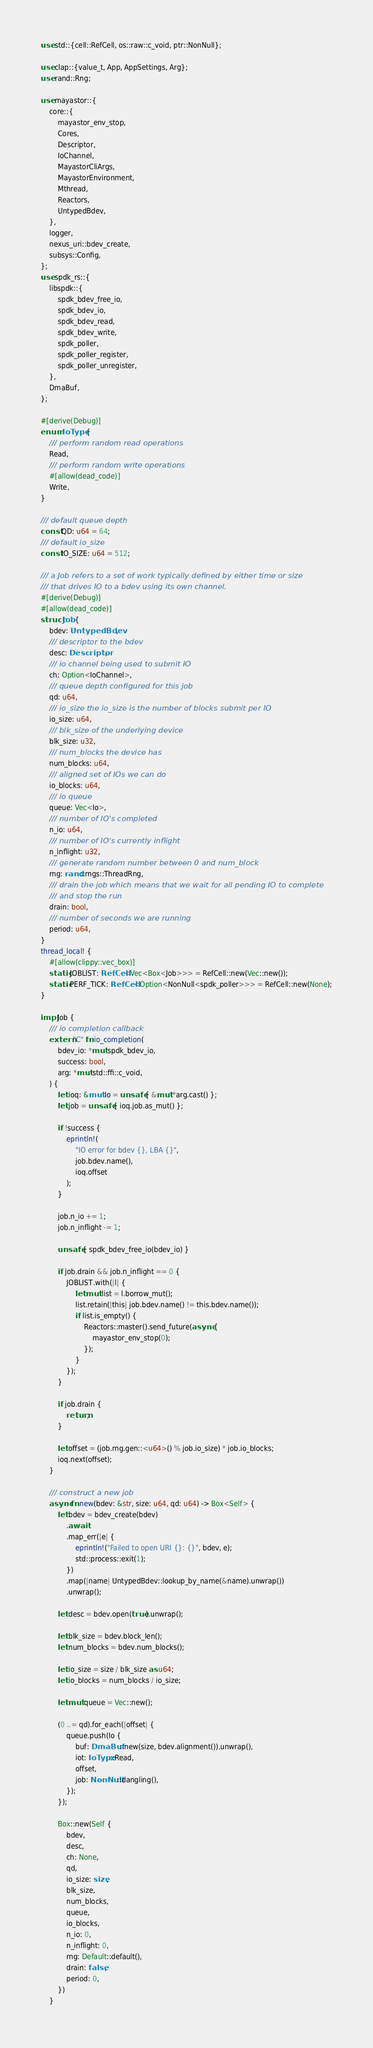Convert code to text. <code><loc_0><loc_0><loc_500><loc_500><_Rust_>use std::{cell::RefCell, os::raw::c_void, ptr::NonNull};

use clap::{value_t, App, AppSettings, Arg};
use rand::Rng;

use mayastor::{
    core::{
        mayastor_env_stop,
        Cores,
        Descriptor,
        IoChannel,
        MayastorCliArgs,
        MayastorEnvironment,
        Mthread,
        Reactors,
        UntypedBdev,
    },
    logger,
    nexus_uri::bdev_create,
    subsys::Config,
};
use spdk_rs::{
    libspdk::{
        spdk_bdev_free_io,
        spdk_bdev_io,
        spdk_bdev_read,
        spdk_bdev_write,
        spdk_poller,
        spdk_poller_register,
        spdk_poller_unregister,
    },
    DmaBuf,
};

#[derive(Debug)]
enum IoType {
    /// perform random read operations
    Read,
    /// perform random write operations
    #[allow(dead_code)]
    Write,
}

/// default queue depth
const QD: u64 = 64;
/// default io_size
const IO_SIZE: u64 = 512;

/// a Job refers to a set of work typically defined by either time or size
/// that drives IO to a bdev using its own channel.
#[derive(Debug)]
#[allow(dead_code)]
struct Job {
    bdev: UntypedBdev,
    /// descriptor to the bdev
    desc: Descriptor,
    /// io channel being used to submit IO
    ch: Option<IoChannel>,
    /// queue depth configured for this job
    qd: u64,
    /// io_size the io_size is the number of blocks submit per IO
    io_size: u64,
    /// blk_size of the underlying device
    blk_size: u32,
    /// num_blocks the device has
    num_blocks: u64,
    /// aligned set of IOs we can do
    io_blocks: u64,
    /// io queue
    queue: Vec<Io>,
    /// number of IO's completed
    n_io: u64,
    /// number of IO's currently inflight
    n_inflight: u32,
    /// generate random number between 0 and num_block
    rng: rand::rngs::ThreadRng,
    /// drain the job which means that we wait for all pending IO to complete
    /// and stop the run
    drain: bool,
    /// number of seconds we are running
    period: u64,
}
thread_local! {
    #[allow(clippy::vec_box)]
    static JOBLIST: RefCell<Vec<Box<Job>>> = RefCell::new(Vec::new());
    static PERF_TICK: RefCell<Option<NonNull<spdk_poller>>> = RefCell::new(None);
}

impl Job {
    /// io completion callback
    extern "C" fn io_completion(
        bdev_io: *mut spdk_bdev_io,
        success: bool,
        arg: *mut std::ffi::c_void,
    ) {
        let ioq: &mut Io = unsafe { &mut *arg.cast() };
        let job = unsafe { ioq.job.as_mut() };

        if !success {
            eprintln!(
                "IO error for bdev {}, LBA {}",
                job.bdev.name(),
                ioq.offset
            );
        }

        job.n_io += 1;
        job.n_inflight -= 1;

        unsafe { spdk_bdev_free_io(bdev_io) }

        if job.drain && job.n_inflight == 0 {
            JOBLIST.with(|l| {
                let mut list = l.borrow_mut();
                list.retain(|this| job.bdev.name() != this.bdev.name());
                if list.is_empty() {
                    Reactors::master().send_future(async {
                        mayastor_env_stop(0);
                    });
                }
            });
        }

        if job.drain {
            return;
        }

        let offset = (job.rng.gen::<u64>() % job.io_size) * job.io_blocks;
        ioq.next(offset);
    }

    /// construct a new job
    async fn new(bdev: &str, size: u64, qd: u64) -> Box<Self> {
        let bdev = bdev_create(bdev)
            .await
            .map_err(|e| {
                eprintln!("Failed to open URI {}: {}", bdev, e);
                std::process::exit(1);
            })
            .map(|name| UntypedBdev::lookup_by_name(&name).unwrap())
            .unwrap();

        let desc = bdev.open(true).unwrap();

        let blk_size = bdev.block_len();
        let num_blocks = bdev.num_blocks();

        let io_size = size / blk_size as u64;
        let io_blocks = num_blocks / io_size;

        let mut queue = Vec::new();

        (0 ..= qd).for_each(|offset| {
            queue.push(Io {
                buf: DmaBuf::new(size, bdev.alignment()).unwrap(),
                iot: IoType::Read,
                offset,
                job: NonNull::dangling(),
            });
        });

        Box::new(Self {
            bdev,
            desc,
            ch: None,
            qd,
            io_size: size,
            blk_size,
            num_blocks,
            queue,
            io_blocks,
            n_io: 0,
            n_inflight: 0,
            rng: Default::default(),
            drain: false,
            period: 0,
        })
    }
</code> 